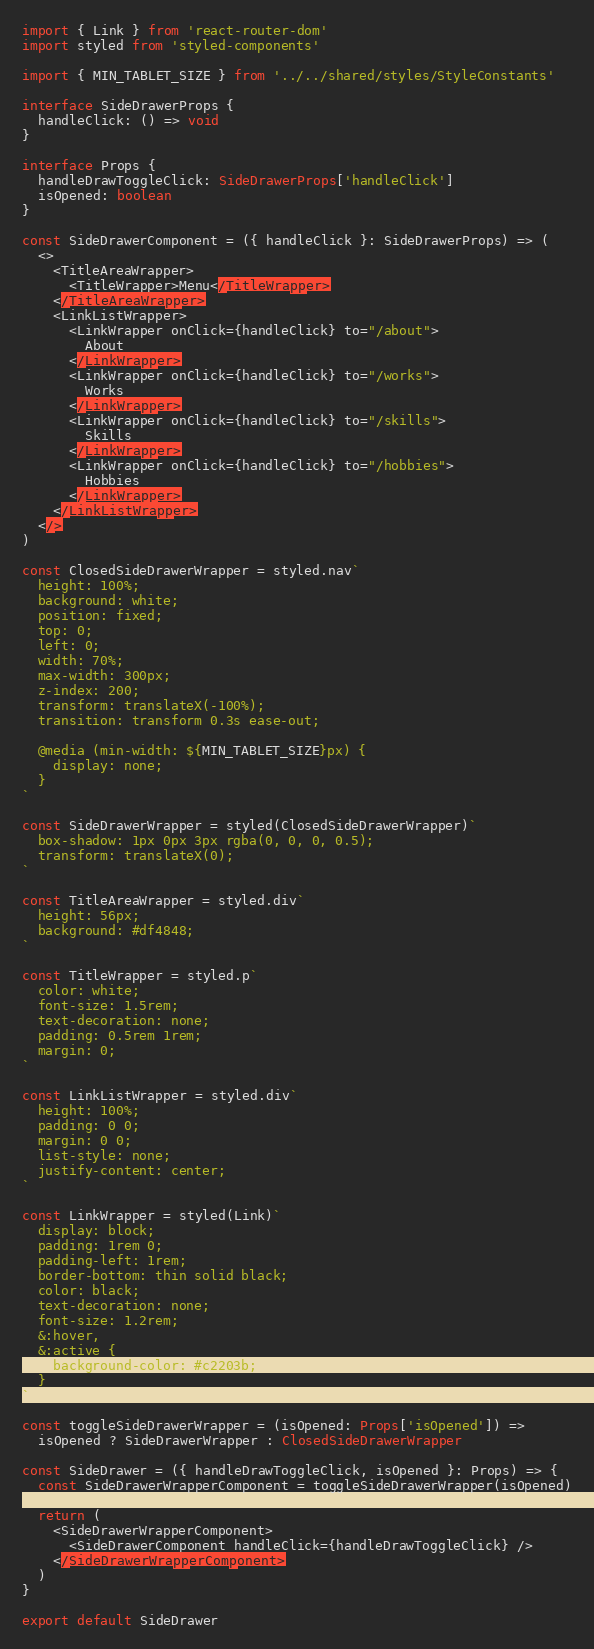Convert code to text. <code><loc_0><loc_0><loc_500><loc_500><_TypeScript_>import { Link } from 'react-router-dom'
import styled from 'styled-components'

import { MIN_TABLET_SIZE } from '../../shared/styles/StyleConstants'

interface SideDrawerProps {
  handleClick: () => void
}

interface Props {
  handleDrawToggleClick: SideDrawerProps['handleClick']
  isOpened: boolean
}

const SideDrawerComponent = ({ handleClick }: SideDrawerProps) => (
  <>
    <TitleAreaWrapper>
      <TitleWrapper>Menu</TitleWrapper>
    </TitleAreaWrapper>
    <LinkListWrapper>
      <LinkWrapper onClick={handleClick} to="/about">
        About
      </LinkWrapper>
      <LinkWrapper onClick={handleClick} to="/works">
        Works
      </LinkWrapper>
      <LinkWrapper onClick={handleClick} to="/skills">
        Skills
      </LinkWrapper>
      <LinkWrapper onClick={handleClick} to="/hobbies">
        Hobbies
      </LinkWrapper>
    </LinkListWrapper>
  </>
)

const ClosedSideDrawerWrapper = styled.nav`
  height: 100%;
  background: white;
  position: fixed;
  top: 0;
  left: 0;
  width: 70%;
  max-width: 300px;
  z-index: 200;
  transform: translateX(-100%);
  transition: transform 0.3s ease-out;

  @media (min-width: ${MIN_TABLET_SIZE}px) {
    display: none;
  }
`

const SideDrawerWrapper = styled(ClosedSideDrawerWrapper)`
  box-shadow: 1px 0px 3px rgba(0, 0, 0, 0.5);
  transform: translateX(0);
`

const TitleAreaWrapper = styled.div`
  height: 56px;
  background: #df4848;
`

const TitleWrapper = styled.p`
  color: white;
  font-size: 1.5rem;
  text-decoration: none;
  padding: 0.5rem 1rem;
  margin: 0;
`

const LinkListWrapper = styled.div`
  height: 100%;
  padding: 0 0;
  margin: 0 0;
  list-style: none;
  justify-content: center;
`

const LinkWrapper = styled(Link)`
  display: block;
  padding: 1rem 0;
  padding-left: 1rem;
  border-bottom: thin solid black;
  color: black;
  text-decoration: none;
  font-size: 1.2rem;
  &:hover,
  &:active {
    background-color: #c2203b;
  }
`

const toggleSideDrawerWrapper = (isOpened: Props['isOpened']) =>
  isOpened ? SideDrawerWrapper : ClosedSideDrawerWrapper

const SideDrawer = ({ handleDrawToggleClick, isOpened }: Props) => {
  const SideDrawerWrapperComponent = toggleSideDrawerWrapper(isOpened)

  return (
    <SideDrawerWrapperComponent>
      <SideDrawerComponent handleClick={handleDrawToggleClick} />
    </SideDrawerWrapperComponent>
  )
}

export default SideDrawer
</code> 